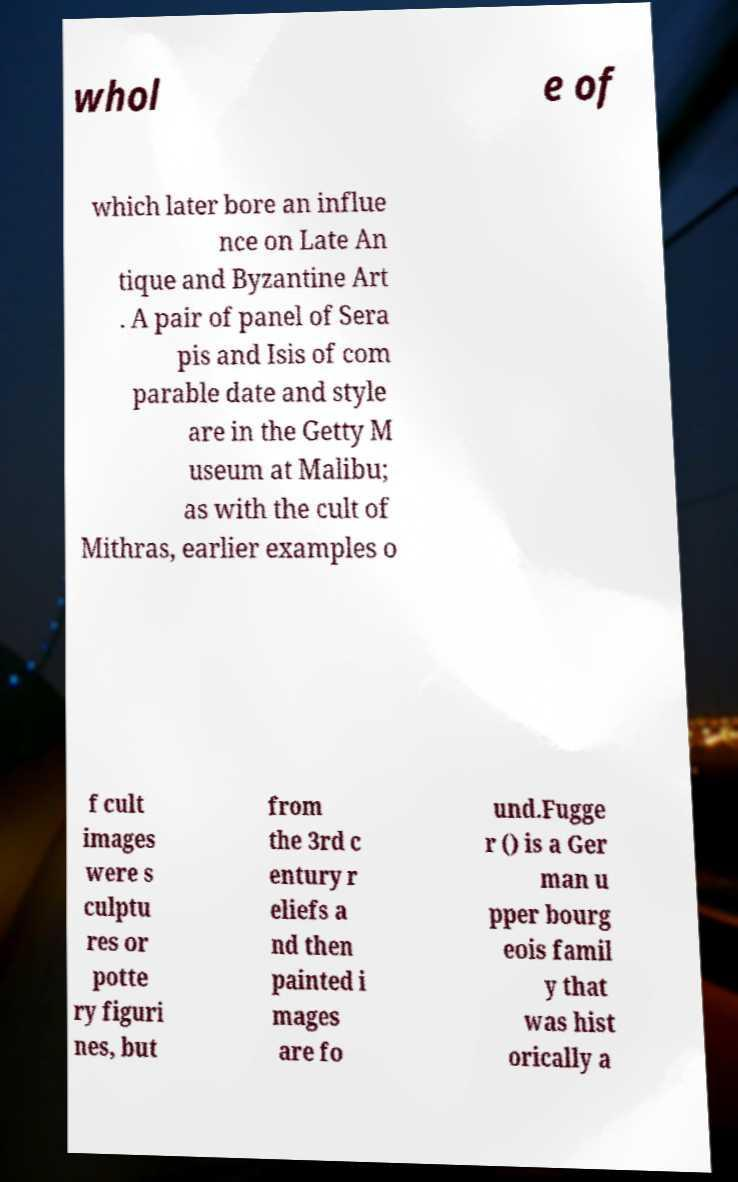Please read and relay the text visible in this image. What does it say? whol e of which later bore an influe nce on Late An tique and Byzantine Art . A pair of panel of Sera pis and Isis of com parable date and style are in the Getty M useum at Malibu; as with the cult of Mithras, earlier examples o f cult images were s culptu res or potte ry figuri nes, but from the 3rd c entury r eliefs a nd then painted i mages are fo und.Fugge r () is a Ger man u pper bourg eois famil y that was hist orically a 